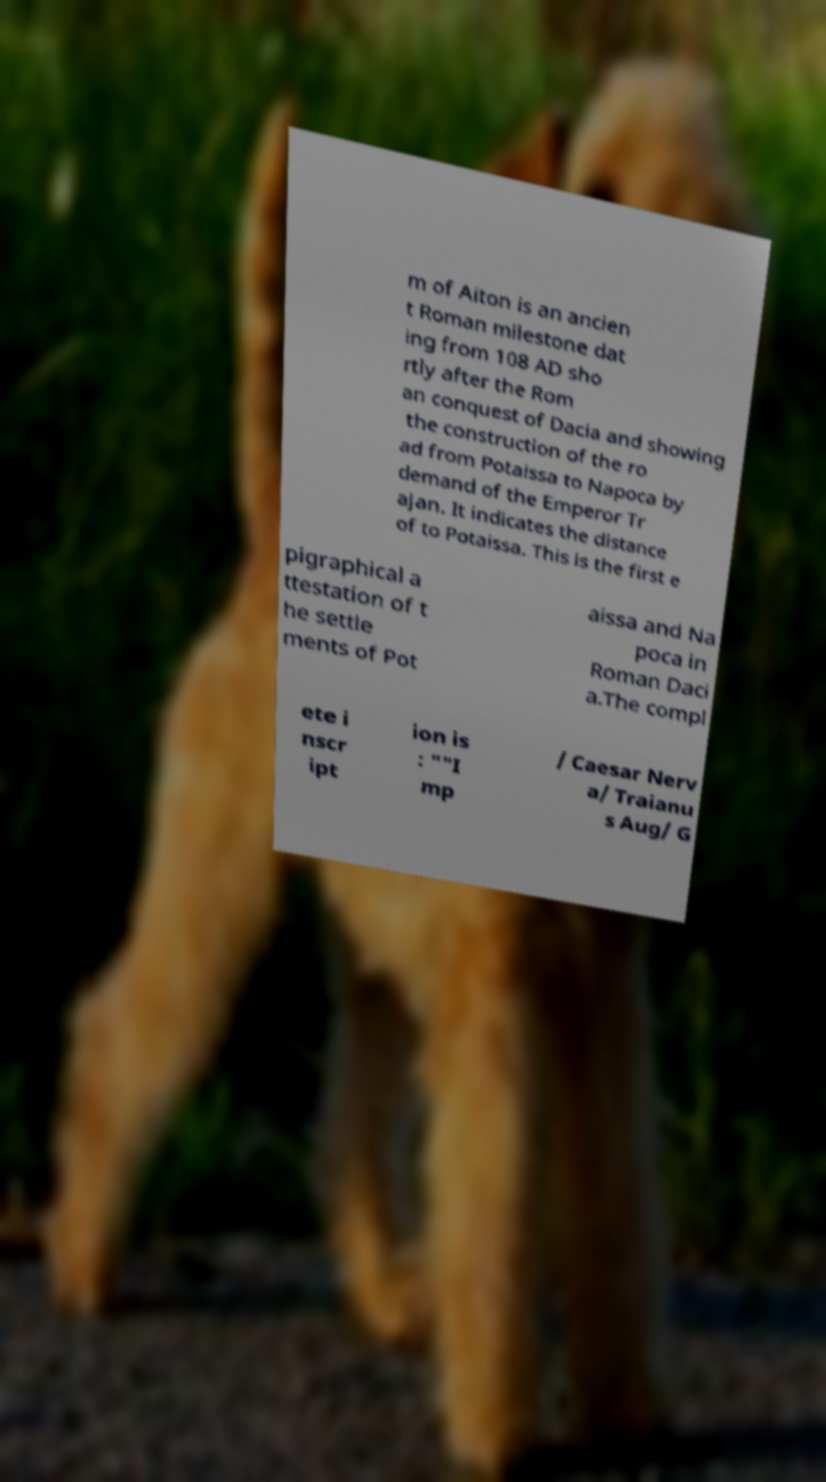For documentation purposes, I need the text within this image transcribed. Could you provide that? m of Aiton is an ancien t Roman milestone dat ing from 108 AD sho rtly after the Rom an conquest of Dacia and showing the construction of the ro ad from Potaissa to Napoca by demand of the Emperor Tr ajan. It indicates the distance of to Potaissa. This is the first e pigraphical a ttestation of t he settle ments of Pot aissa and Na poca in Roman Daci a.The compl ete i nscr ipt ion is : ""I mp / Caesar Nerv a/ Traianu s Aug/ G 